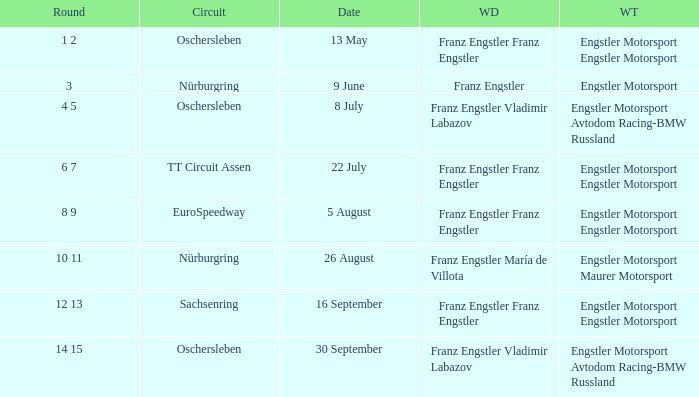What Winning team has 22 July as a Date? Engstler Motorsport Engstler Motorsport. 